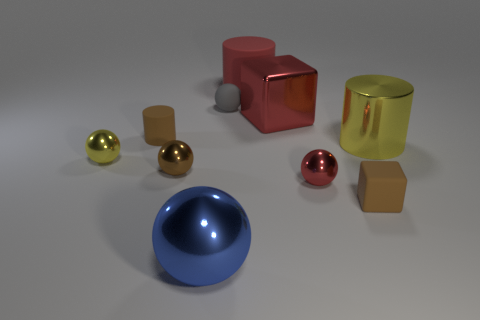Subtract all small balls. How many balls are left? 1 Subtract 3 balls. How many balls are left? 2 Subtract all gray balls. How many balls are left? 4 Subtract all blocks. How many objects are left? 8 Subtract all small blue cylinders. Subtract all large cylinders. How many objects are left? 8 Add 9 tiny brown metallic spheres. How many tiny brown metallic spheres are left? 10 Add 9 big purple metal cylinders. How many big purple metal cylinders exist? 9 Subtract 0 gray cylinders. How many objects are left? 10 Subtract all gray cylinders. Subtract all blue spheres. How many cylinders are left? 3 Subtract all green spheres. How many gray cylinders are left? 0 